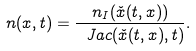Convert formula to latex. <formula><loc_0><loc_0><loc_500><loc_500>n ( x , t ) = \frac { n _ { I } ( \check { x } ( t , x ) ) } { \ J a c ( \check { x } ( t , x ) , t ) } .</formula> 